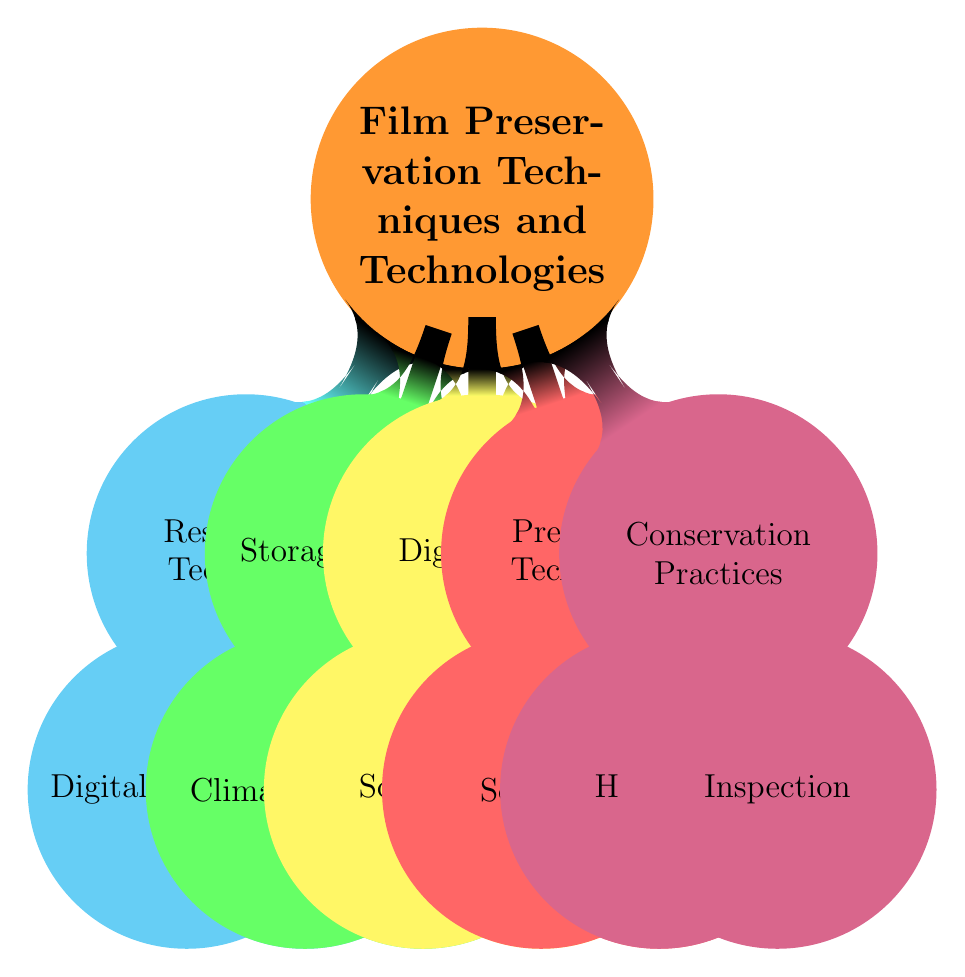What is the central topic of the diagram? The central topic is clearly labeled at the root of the diagram. It is the primary focus around which all other nodes are organized.
Answer: Film Preservation Techniques and Technologies How many subtopics are associated with the central topic? Counting the direct children of the central topic reveals that there are five distinct subtopics branching out.
Answer: 5 Name a method listed under Digital Restoration. Examining the "Digital Restoration" node, we can see that multiple techniques are listed. Selecting one from the list provides the answer.
Answer: Dust and Scratch Removal Which subtopic includes "Temperature Regulation"? By analyzing each subtopic, we find that "Temperature Regulation" is specifically located under the "Climate Control" node, which is a part of "Storage Solutions."
Answer: Storage Solutions What are the two main types of Restoration Techniques? Looking closely at the "Restoration Techniques" node, it shows that it is branched into two primary categories. Thus, identifying those two will answer the question.
Answer: Digital Restoration, Physical Restoration How is "Proper Film Handling Protocols" categorized in the mind map? By reviewing the structure of the mind map, "Proper Film Handling Protocols" is a node that falls under one of the subtopics, specifically under Conservation Practices.
Answer: Conservation Practices Which type of preservation technology includes Adobe After Effects? Checking within the "Preservation Technologies" subtopic leads us to find that "Adobe After Effects" is categorized under the Software node.
Answer: Software How many nodes are under the subtopic "Storage Solutions"? We observe the "Storage Solutions" subtopic, which is further expanded into its components. Counting these components directly gives us the answer.
Answer: 2 What is a key practice in Conservation Practices that involves film condition? Under the "Conservation Practices" subtopic, we locate a specific node concerned with film state assessments. Identifying it provides the answer.
Answer: Inspection 